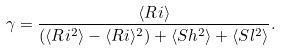<formula> <loc_0><loc_0><loc_500><loc_500>\gamma = \frac { \langle R i \rangle } { ( \langle R i ^ { 2 } \rangle - \langle R i \rangle ^ { 2 } ) + \langle S h ^ { 2 } \rangle + \langle S l ^ { 2 } \rangle } .</formula> 